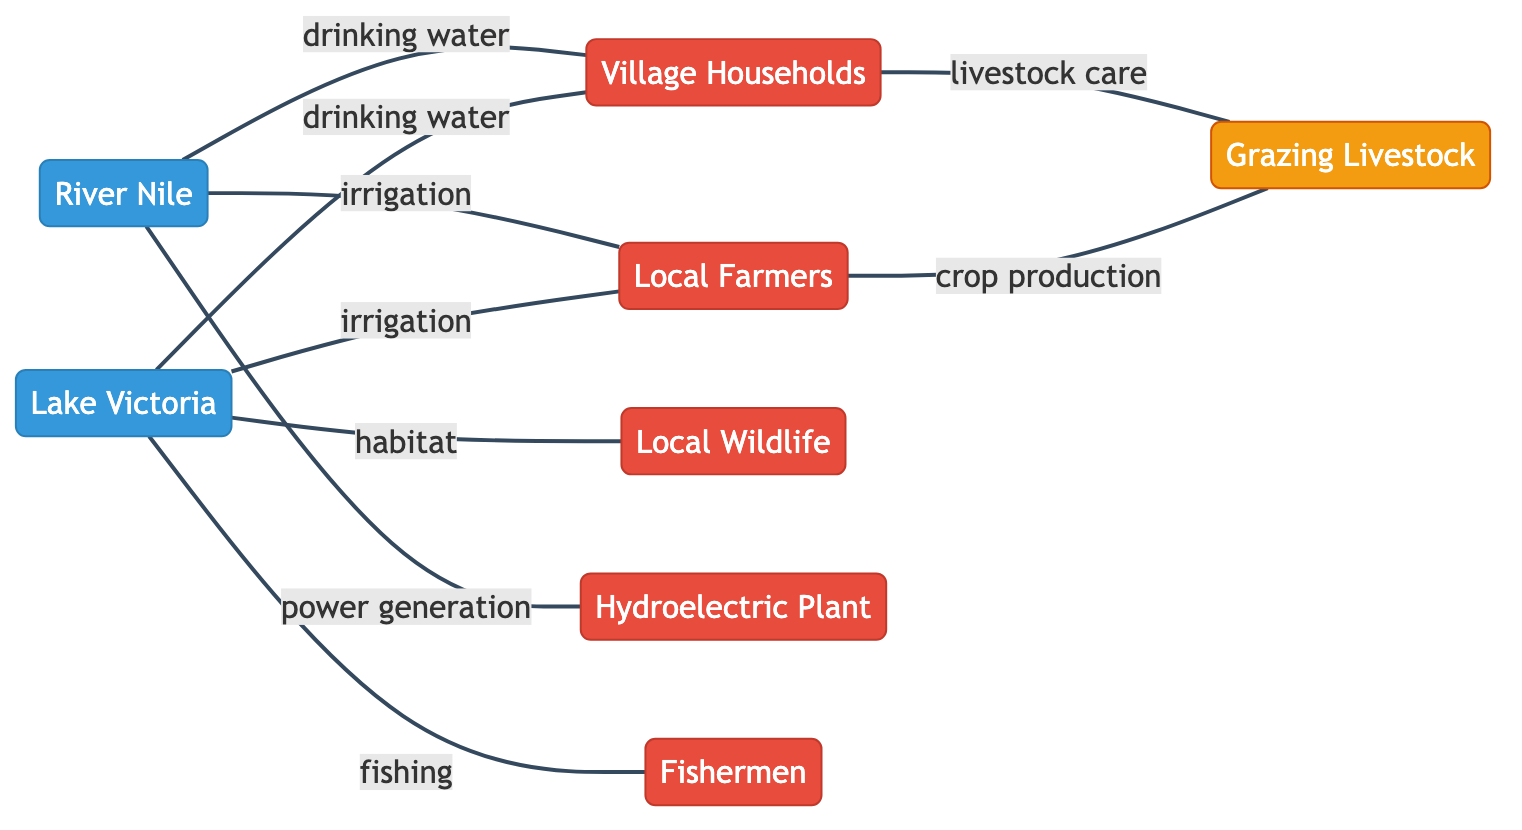What are the nodes in this graph? The nodes in this graph are Lake Victoria, Local Farmers, Village Households, Local Wildlife, River Nile, Hydroelectric Plant, Fishermen, and Grazing Livestock. These can be identified by looking at the nodes section in the diagram.
Answer: Lake Victoria, Local Farmers, Village Households, Local Wildlife, River Nile, Hydroelectric Plant, Fishermen, Grazing Livestock How many edges connect Lake Victoria? Lake Victoria has four edges connecting it to Local Farmers, Village Households, Local Wildlife, and Fishermen. By examining the edges linked to Lake Victoria, we can count them to determine the total.
Answer: 4 What type of relationship exists between River Nile and Local Farmers? The relationship between River Nile and Local Farmers is "irrigation." This can be determined from the label on the edge connecting these two nodes.
Answer: irrigation Which user is linked to Grazing Livestock for crop production? Local Farmers are linked to Grazing Livestock for crop production. This is shown by the direct edge connecting these two nodes with the label "crop production."
Answer: Local Farmers What is the relationship between River Nile and the Hydroelectric Plant? The relationship between River Nile and the Hydroelectric Plant is "power generation." The edge between these two nodes specifies that relationship clearly.
Answer: power generation How many nodes represent water sources? There are two nodes that represent water sources: Lake Victoria and River Nile. By identifying the nodes associated with water, we count them to arrive at the total.
Answer: 2 Which user has the most connections to water sources? Local Farmers have the most connections to water sources, linked to both Lake Victoria and River Nile through irrigation. By checking the edges, we can see that Local Farmers connect with two water sources.
Answer: Local Farmers Which animal group utilizes water from Lake Victoria? Local Wildlife utilize water from Lake Victoria, as indicated by the edge labeled "habitat." This connection shows that they have a relationship with Lake Victoria.
Answer: Local Wildlife 